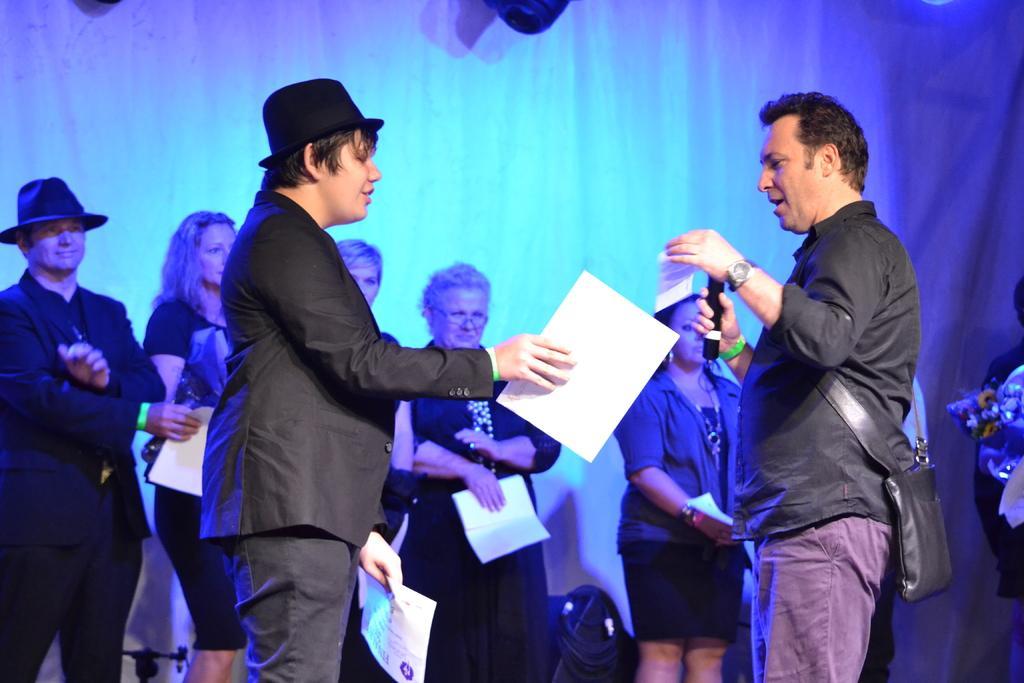In one or two sentences, can you explain what this image depicts? In the foreground I can see two men are standing facing at each other, holding papers in the hands and speaking something. The man who is on the right side is holding a mike in the hand. In the background, I can see some more people are standing by holding papers in the hands and looking at these people. At the back of these people I can see a white color curtain. 